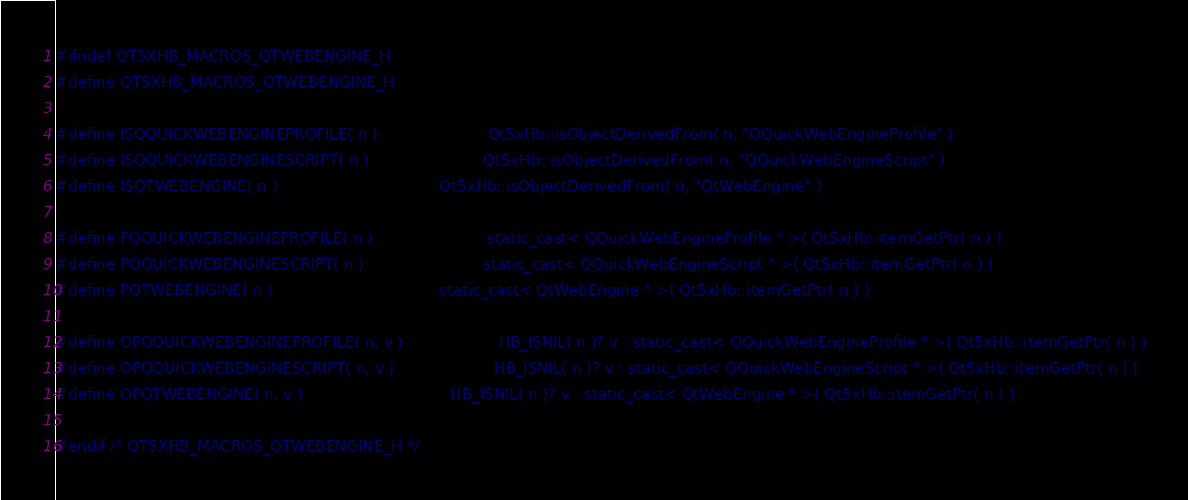<code> <loc_0><loc_0><loc_500><loc_500><_C_>
#ifndef QT5XHB_MACROS_QTWEBENGINE_H
#define QT5XHB_MACROS_QTWEBENGINE_H

#define ISQQUICKWEBENGINEPROFILE( n )                       Qt5xHb::isObjectDerivedFrom( n, "QQuickWebEngineProfile" )
#define ISQQUICKWEBENGINESCRIPT( n )                        Qt5xHb::isObjectDerivedFrom( n, "QQuickWebEngineScript" )
#define ISQTWEBENGINE( n )                                  Qt5xHb::isObjectDerivedFrom( n, "QtWebEngine" )

#define PQQUICKWEBENGINEPROFILE( n )                        static_cast< QQuickWebEngineProfile * >( Qt5xHb::itemGetPtr( n ) )
#define PQQUICKWEBENGINESCRIPT( n )                         static_cast< QQuickWebEngineScript * >( Qt5xHb::itemGetPtr( n ) )
#define PQTWEBENGINE( n )                                   static_cast< QtWebEngine * >( Qt5xHb::itemGetPtr( n ) )

#define OPQQUICKWEBENGINEPROFILE( n, v )                    HB_ISNIL( n )? v : static_cast< QQuickWebEngineProfile * >( Qt5xHb::itemGetPtr( n ) )
#define OPQQUICKWEBENGINESCRIPT( n, v )                     HB_ISNIL( n )? v : static_cast< QQuickWebEngineScript * >( Qt5xHb::itemGetPtr( n ) )
#define OPQTWEBENGINE( n, v )                               HB_ISNIL( n )? v : static_cast< QtWebEngine * >( Qt5xHb::itemGetPtr( n ) )

#endif /* QT5XHB_MACROS_QTWEBENGINE_H */
</code> 